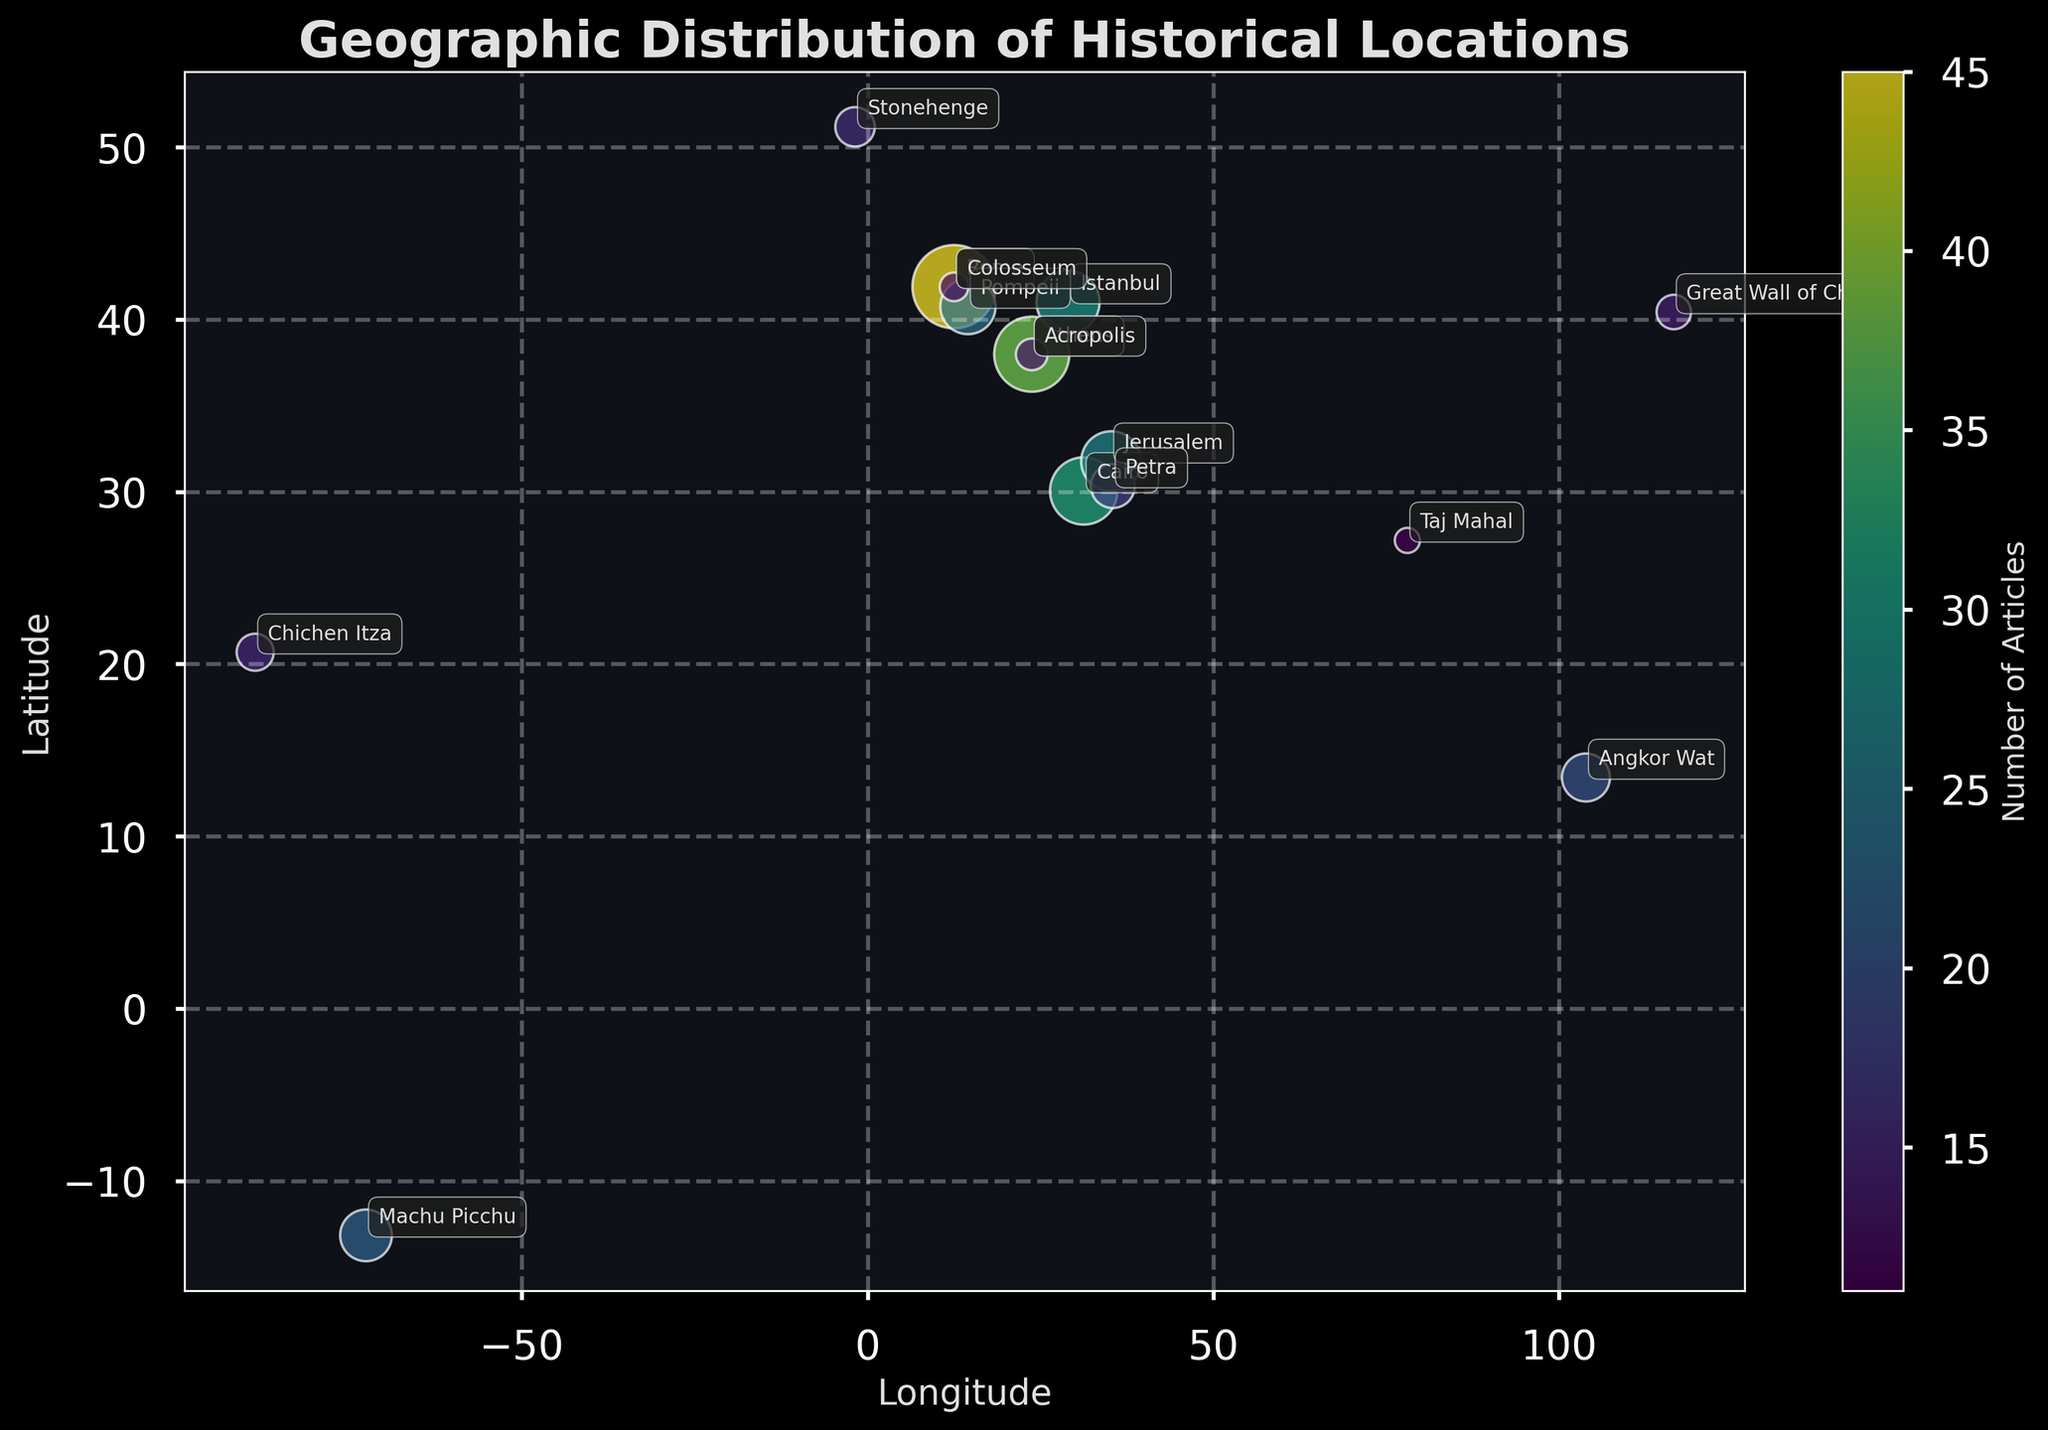What's the title of the figure? The title is located at the top of the figure, written in a larger, bold font, typically centered. Here, it reads: "Geographic Distribution of Historical Locations".
Answer: Geographic Distribution of Historical Locations What does the size of the bubbles represent? The bubble size corresponds to the number of articles written about each historical location. Larger bubbles signify more articles.
Answer: Number of articles written What are the axes labels? The axes labels can be found along the edges of the plot. The x-axis represents 'Longitude', and the y-axis represents 'Latitude'. These are noted at the end of each axis line.
Answer: Longitude (x-axis), Latitude (y-axis) Which location has the largest bubble, and what does it signify? The largest bubble is found at the coordinates (41.9028, 12.4964), representing Rome. This indicates Rome has the highest number of articles written about it, which is 45.
Answer: Rome (45 articles) Are there more articles written about Jerusalem or Istanbul? Comparing the bubble sizes and the numbers annotated near them, Istanbul has 29 articles, while Jerusalem has 27 articles.
Answer: Istanbul How does the number of articles about Petra compare to that about Stonehenge and Chichen Itza combined? Petra has 18 articles. Stonehenge has 16, and Chichen Itza has 15. Combining Stonehenge and Chichen Itza gives 16 + 15 = 31, greater than the 18 articles about Petra.
Answer: Petra: 18, Stonehenge + Chichen Itza: 31 (31 > 18) Which continent has the highest concentration of articles written based on the plotted locations? Most of the historical locations with larger bubbles (e.g., Rome, Athens, Istanbul) are in Europe. This indicates a high concentration of articles written about European locations.
Answer: Europe How do the bubble colors correspond to the data? The figure uses a color gradient (viridis) where bubbles transition from cooler to warmer colors based on the number of articles. Warmer colors indicate a higher number of articles.
Answer: Color gradient indicates article count Is there an outlier in the Southern Hemisphere with regards to the number of articles written? Machu Picchu, located at -13.1631 latitude in the Southern Hemisphere, has 22 articles. It is an outlier as it is relatively detached geographically from other locations with many articles.
Answer: Machu Picchu (22 articles) 